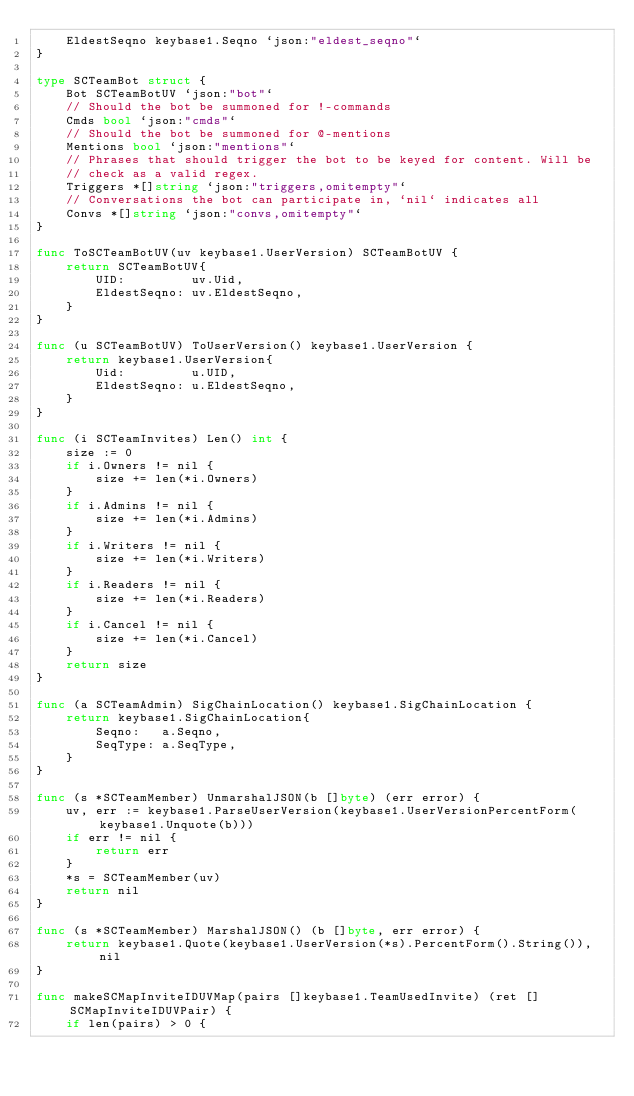<code> <loc_0><loc_0><loc_500><loc_500><_Go_>	EldestSeqno keybase1.Seqno `json:"eldest_seqno"`
}

type SCTeamBot struct {
	Bot SCTeamBotUV `json:"bot"`
	// Should the bot be summoned for !-commands
	Cmds bool `json:"cmds"`
	// Should the bot be summoned for @-mentions
	Mentions bool `json:"mentions"`
	// Phrases that should trigger the bot to be keyed for content. Will be
	// check as a valid regex.
	Triggers *[]string `json:"triggers,omitempty"`
	// Conversations the bot can participate in, `nil` indicates all
	Convs *[]string `json:"convs,omitempty"`
}

func ToSCTeamBotUV(uv keybase1.UserVersion) SCTeamBotUV {
	return SCTeamBotUV{
		UID:         uv.Uid,
		EldestSeqno: uv.EldestSeqno,
	}
}

func (u SCTeamBotUV) ToUserVersion() keybase1.UserVersion {
	return keybase1.UserVersion{
		Uid:         u.UID,
		EldestSeqno: u.EldestSeqno,
	}
}

func (i SCTeamInvites) Len() int {
	size := 0
	if i.Owners != nil {
		size += len(*i.Owners)
	}
	if i.Admins != nil {
		size += len(*i.Admins)
	}
	if i.Writers != nil {
		size += len(*i.Writers)
	}
	if i.Readers != nil {
		size += len(*i.Readers)
	}
	if i.Cancel != nil {
		size += len(*i.Cancel)
	}
	return size
}

func (a SCTeamAdmin) SigChainLocation() keybase1.SigChainLocation {
	return keybase1.SigChainLocation{
		Seqno:   a.Seqno,
		SeqType: a.SeqType,
	}
}

func (s *SCTeamMember) UnmarshalJSON(b []byte) (err error) {
	uv, err := keybase1.ParseUserVersion(keybase1.UserVersionPercentForm(keybase1.Unquote(b)))
	if err != nil {
		return err
	}
	*s = SCTeamMember(uv)
	return nil
}

func (s *SCTeamMember) MarshalJSON() (b []byte, err error) {
	return keybase1.Quote(keybase1.UserVersion(*s).PercentForm().String()), nil
}

func makeSCMapInviteIDUVMap(pairs []keybase1.TeamUsedInvite) (ret []SCMapInviteIDUVPair) {
	if len(pairs) > 0 {</code> 